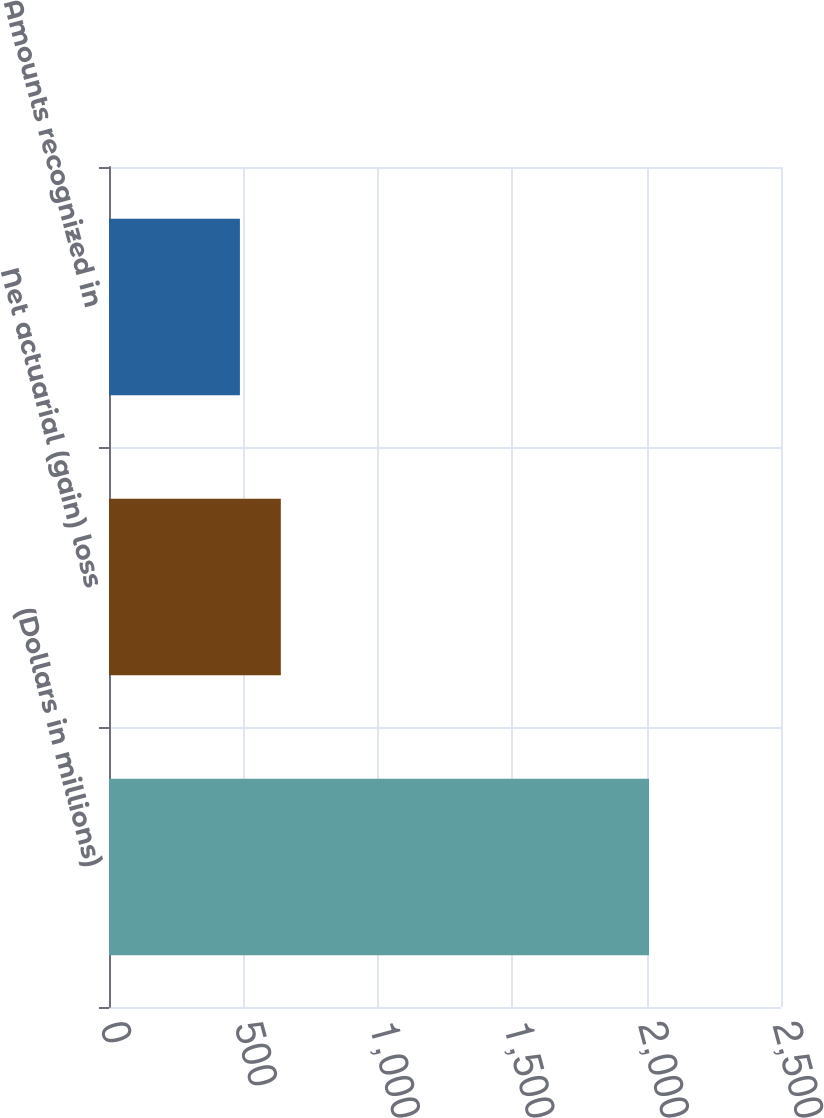Convert chart to OTSL. <chart><loc_0><loc_0><loc_500><loc_500><bar_chart><fcel>(Dollars in millions)<fcel>Net actuarial (gain) loss<fcel>Amounts recognized in<nl><fcel>2009<fcel>639.2<fcel>487<nl></chart> 